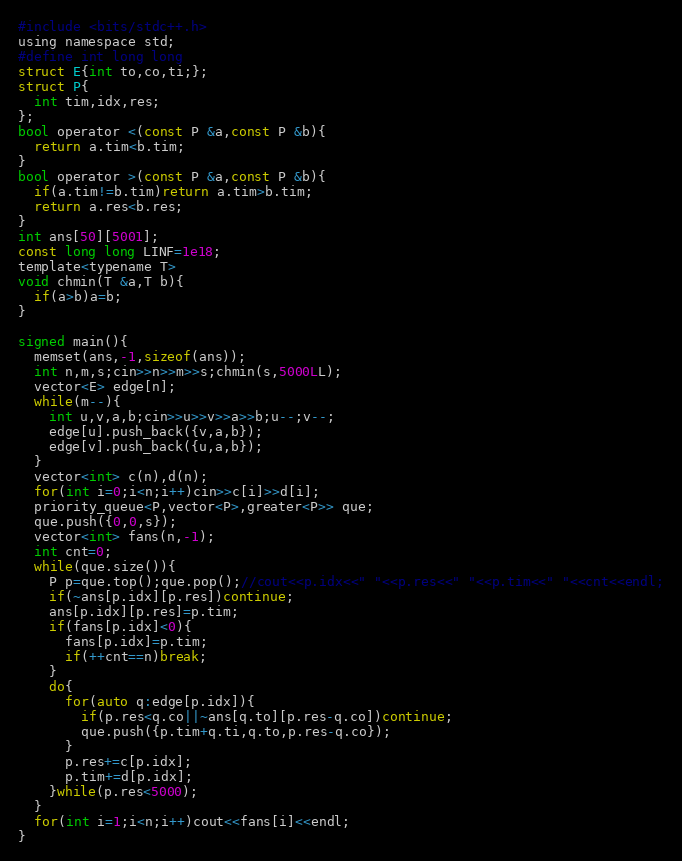<code> <loc_0><loc_0><loc_500><loc_500><_C_>#include <bits/stdc++.h>
using namespace std;
#define int long long
struct E{int to,co,ti;};
struct P{
  int tim,idx,res;
};
bool operator <(const P &a,const P &b){
  return a.tim<b.tim;
}
bool operator >(const P &a,const P &b){
  if(a.tim!=b.tim)return a.tim>b.tim;
  return a.res<b.res;
}
int ans[50][5001];
const long long LINF=1e18;
template<typename T>
void chmin(T &a,T b){
  if(a>b)a=b;
}

signed main(){
  memset(ans,-1,sizeof(ans));
  int n,m,s;cin>>n>>m>>s;chmin(s,5000LL);
  vector<E> edge[n];
  while(m--){
    int u,v,a,b;cin>>u>>v>>a>>b;u--;v--;
    edge[u].push_back({v,a,b});
    edge[v].push_back({u,a,b});
  }
  vector<int> c(n),d(n);
  for(int i=0;i<n;i++)cin>>c[i]>>d[i];
  priority_queue<P,vector<P>,greater<P>> que;
  que.push({0,0,s});
  vector<int> fans(n,-1);
  int cnt=0;
  while(que.size()){
    P p=que.top();que.pop();//cout<<p.idx<<" "<<p.res<<" "<<p.tim<<" "<<cnt<<endl;
    if(~ans[p.idx][p.res])continue;
    ans[p.idx][p.res]=p.tim;
    if(fans[p.idx]<0){
      fans[p.idx]=p.tim;
      if(++cnt==n)break;
    }
    do{
      for(auto q:edge[p.idx]){
        if(p.res<q.co||~ans[q.to][p.res-q.co])continue;
        que.push({p.tim+q.ti,q.to,p.res-q.co});
      }
      p.res+=c[p.idx];
      p.tim+=d[p.idx];
    }while(p.res<5000);
  }
  for(int i=1;i<n;i++)cout<<fans[i]<<endl;
}
</code> 